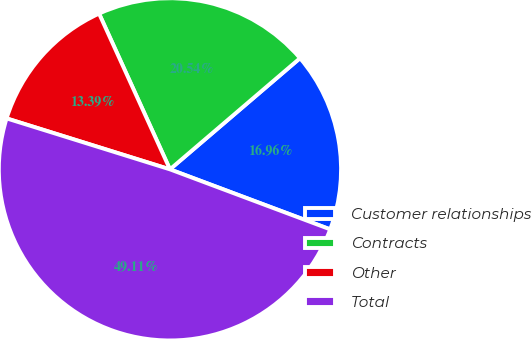Convert chart. <chart><loc_0><loc_0><loc_500><loc_500><pie_chart><fcel>Customer relationships<fcel>Contracts<fcel>Other<fcel>Total<nl><fcel>16.96%<fcel>20.54%<fcel>13.39%<fcel>49.11%<nl></chart> 